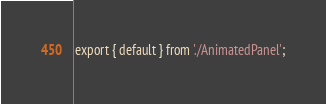Convert code to text. <code><loc_0><loc_0><loc_500><loc_500><_JavaScript_>export { default } from './AnimatedPanel';
</code> 